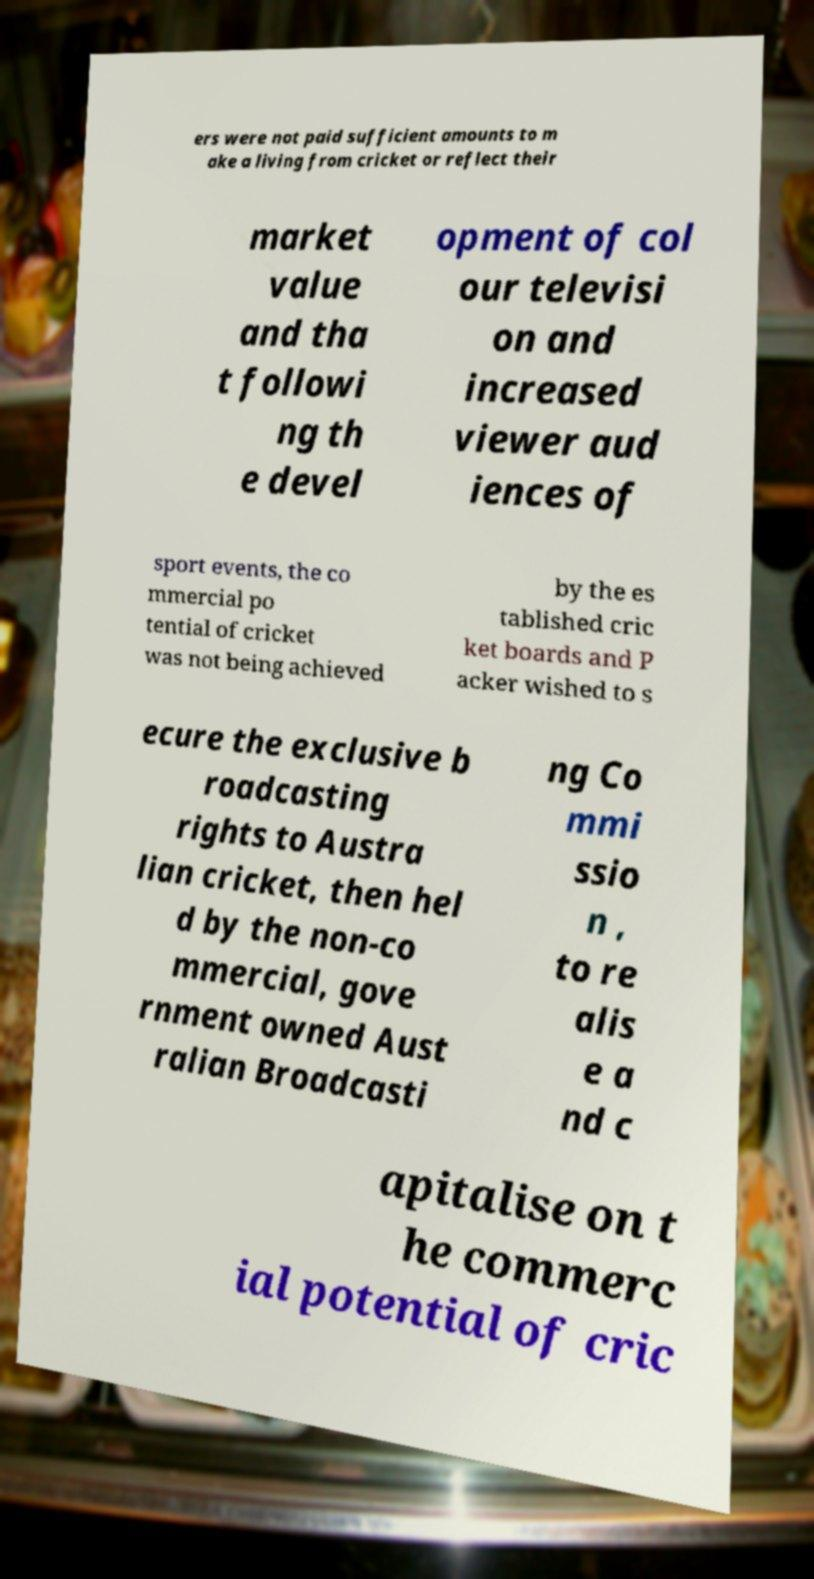Please identify and transcribe the text found in this image. ers were not paid sufficient amounts to m ake a living from cricket or reflect their market value and tha t followi ng th e devel opment of col our televisi on and increased viewer aud iences of sport events, the co mmercial po tential of cricket was not being achieved by the es tablished cric ket boards and P acker wished to s ecure the exclusive b roadcasting rights to Austra lian cricket, then hel d by the non-co mmercial, gove rnment owned Aust ralian Broadcasti ng Co mmi ssio n , to re alis e a nd c apitalise on t he commerc ial potential of cric 